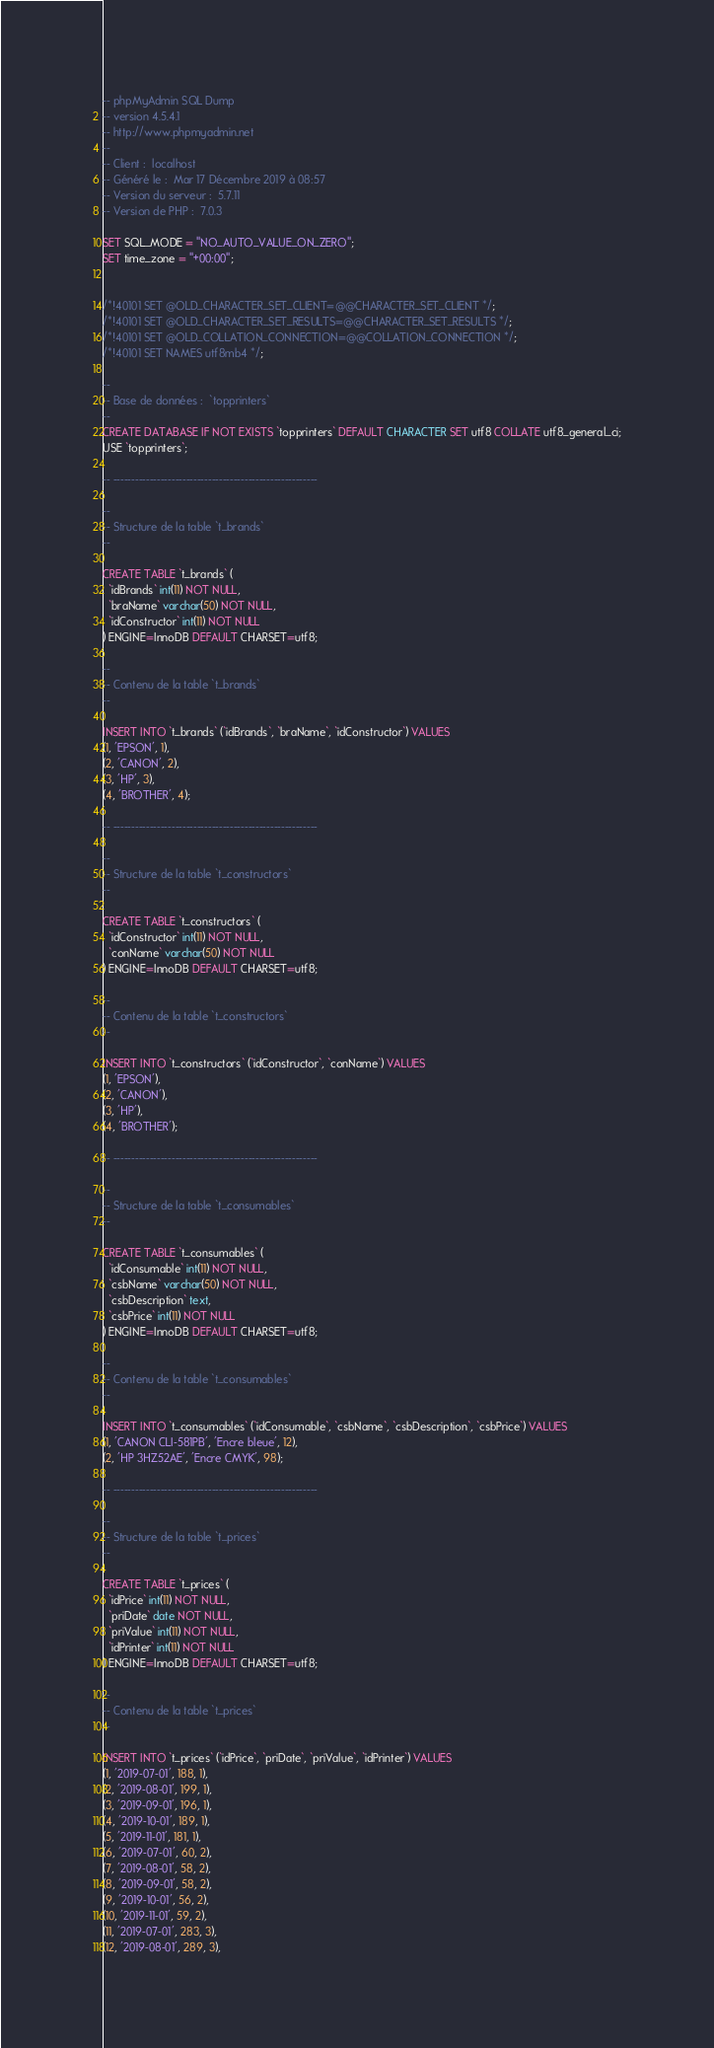<code> <loc_0><loc_0><loc_500><loc_500><_SQL_>-- phpMyAdmin SQL Dump
-- version 4.5.4.1
-- http://www.phpmyadmin.net
--
-- Client :  localhost
-- Généré le :  Mar 17 Décembre 2019 à 08:57
-- Version du serveur :  5.7.11
-- Version de PHP :  7.0.3

SET SQL_MODE = "NO_AUTO_VALUE_ON_ZERO";
SET time_zone = "+00:00";


/*!40101 SET @OLD_CHARACTER_SET_CLIENT=@@CHARACTER_SET_CLIENT */;
/*!40101 SET @OLD_CHARACTER_SET_RESULTS=@@CHARACTER_SET_RESULTS */;
/*!40101 SET @OLD_COLLATION_CONNECTION=@@COLLATION_CONNECTION */;
/*!40101 SET NAMES utf8mb4 */;

--
-- Base de données :  `topprinters`
--
CREATE DATABASE IF NOT EXISTS `topprinters` DEFAULT CHARACTER SET utf8 COLLATE utf8_general_ci;
USE `topprinters`;

-- --------------------------------------------------------

--
-- Structure de la table `t_brands`
--

CREATE TABLE `t_brands` (
  `idBrands` int(11) NOT NULL,
  `braName` varchar(50) NOT NULL,
  `idConstructor` int(11) NOT NULL
) ENGINE=InnoDB DEFAULT CHARSET=utf8;

--
-- Contenu de la table `t_brands`
--

INSERT INTO `t_brands` (`idBrands`, `braName`, `idConstructor`) VALUES
(1, 'EPSON', 1),
(2, 'CANON', 2),
(3, 'HP', 3),
(4, 'BROTHER', 4);

-- --------------------------------------------------------

--
-- Structure de la table `t_constructors`
--

CREATE TABLE `t_constructors` (
  `idConstructor` int(11) NOT NULL,
  `conName` varchar(50) NOT NULL
) ENGINE=InnoDB DEFAULT CHARSET=utf8;

--
-- Contenu de la table `t_constructors`
--

INSERT INTO `t_constructors` (`idConstructor`, `conName`) VALUES
(1, 'EPSON'),
(2, 'CANON'),
(3, 'HP'),
(4, 'BROTHER');

-- --------------------------------------------------------

--
-- Structure de la table `t_consumables`
--

CREATE TABLE `t_consumables` (
  `idConsumable` int(11) NOT NULL,
  `csbName` varchar(50) NOT NULL,
  `csbDescription` text,
  `csbPrice` int(11) NOT NULL
) ENGINE=InnoDB DEFAULT CHARSET=utf8;

--
-- Contenu de la table `t_consumables`
--

INSERT INTO `t_consumables` (`idConsumable`, `csbName`, `csbDescription`, `csbPrice`) VALUES
(1, 'CANON CLI-581PB', 'Encre bleue', 12),
(2, 'HP 3HZ52AE', 'Encre CMYK', 98);

-- --------------------------------------------------------

--
-- Structure de la table `t_prices`
--

CREATE TABLE `t_prices` (
  `idPrice` int(11) NOT NULL,
  `priDate` date NOT NULL,
  `priValue` int(11) NOT NULL,
  `idPrinter` int(11) NOT NULL
) ENGINE=InnoDB DEFAULT CHARSET=utf8;

--
-- Contenu de la table `t_prices`
--

INSERT INTO `t_prices` (`idPrice`, `priDate`, `priValue`, `idPrinter`) VALUES
(1, '2019-07-01', 188, 1),
(2, '2019-08-01', 199, 1),
(3, '2019-09-01', 196, 1),
(4, '2019-10-01', 189, 1),
(5, '2019-11-01', 181, 1),
(6, '2019-07-01', 60, 2),
(7, '2019-08-01', 58, 2),
(8, '2019-09-01', 58, 2),
(9, '2019-10-01', 56, 2),
(10, '2019-11-01', 59, 2),
(11, '2019-07-01', 283, 3),
(12, '2019-08-01', 289, 3),</code> 